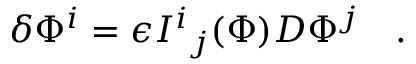Convert formula to latex. <formula><loc_0><loc_0><loc_500><loc_500>\delta \Phi ^ { i } = \epsilon { I ^ { i } } _ { j } ( \Phi ) D \Phi ^ { j } \quad .</formula> 